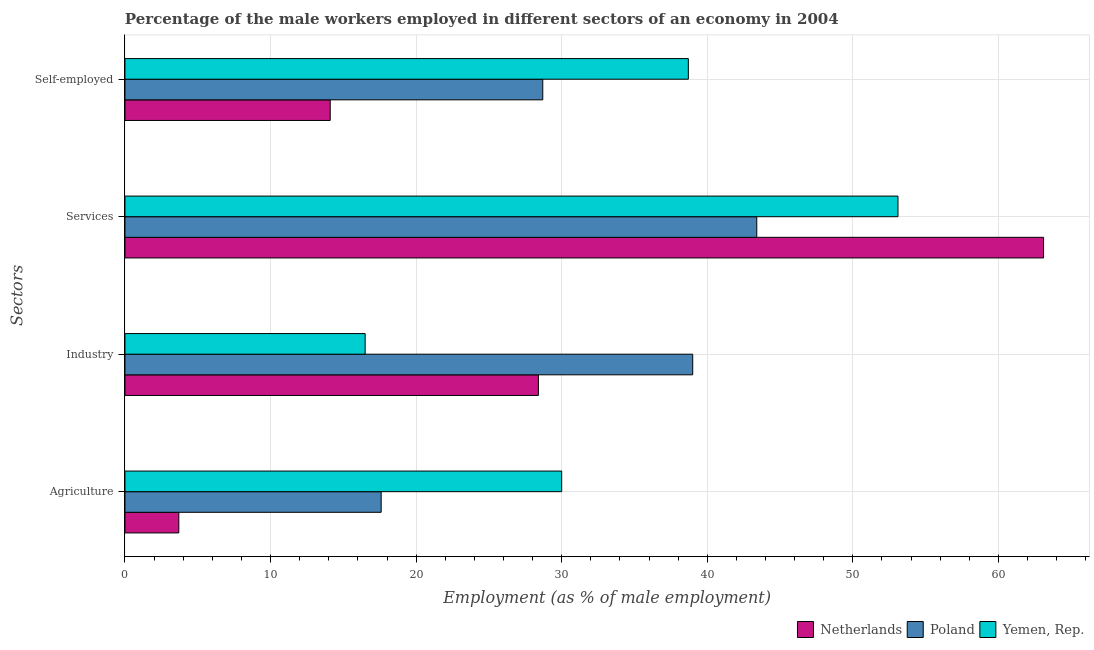Are the number of bars per tick equal to the number of legend labels?
Your answer should be compact. Yes. Are the number of bars on each tick of the Y-axis equal?
Offer a terse response. Yes. How many bars are there on the 4th tick from the bottom?
Offer a terse response. 3. What is the label of the 2nd group of bars from the top?
Provide a succinct answer. Services. What is the percentage of male workers in agriculture in Netherlands?
Your answer should be compact. 3.7. In which country was the percentage of male workers in agriculture maximum?
Your answer should be very brief. Yemen, Rep. What is the total percentage of self employed male workers in the graph?
Your answer should be compact. 81.5. What is the difference between the percentage of self employed male workers in Poland and that in Yemen, Rep.?
Provide a short and direct response. -10. What is the difference between the percentage of self employed male workers in Netherlands and the percentage of male workers in industry in Yemen, Rep.?
Ensure brevity in your answer.  -2.4. What is the average percentage of male workers in services per country?
Your answer should be compact. 53.2. What is the difference between the percentage of male workers in agriculture and percentage of male workers in industry in Yemen, Rep.?
Your answer should be very brief. 13.5. What is the ratio of the percentage of male workers in industry in Poland to that in Yemen, Rep.?
Your response must be concise. 2.36. Is the difference between the percentage of male workers in agriculture in Yemen, Rep. and Netherlands greater than the difference between the percentage of self employed male workers in Yemen, Rep. and Netherlands?
Keep it short and to the point. Yes. What is the difference between the highest and the second highest percentage of self employed male workers?
Provide a succinct answer. 10. What is the difference between the highest and the lowest percentage of male workers in services?
Your response must be concise. 19.7. Is the sum of the percentage of male workers in industry in Yemen, Rep. and Netherlands greater than the maximum percentage of male workers in services across all countries?
Provide a succinct answer. No. Is it the case that in every country, the sum of the percentage of self employed male workers and percentage of male workers in industry is greater than the sum of percentage of male workers in agriculture and percentage of male workers in services?
Provide a succinct answer. No. What does the 1st bar from the top in Services represents?
Provide a short and direct response. Yemen, Rep. What does the 3rd bar from the bottom in Industry represents?
Give a very brief answer. Yemen, Rep. Are the values on the major ticks of X-axis written in scientific E-notation?
Make the answer very short. No. Does the graph contain any zero values?
Give a very brief answer. No. Does the graph contain grids?
Ensure brevity in your answer.  Yes. How many legend labels are there?
Make the answer very short. 3. What is the title of the graph?
Your answer should be very brief. Percentage of the male workers employed in different sectors of an economy in 2004. What is the label or title of the X-axis?
Your response must be concise. Employment (as % of male employment). What is the label or title of the Y-axis?
Provide a succinct answer. Sectors. What is the Employment (as % of male employment) in Netherlands in Agriculture?
Offer a terse response. 3.7. What is the Employment (as % of male employment) in Poland in Agriculture?
Ensure brevity in your answer.  17.6. What is the Employment (as % of male employment) in Netherlands in Industry?
Your response must be concise. 28.4. What is the Employment (as % of male employment) in Yemen, Rep. in Industry?
Keep it short and to the point. 16.5. What is the Employment (as % of male employment) in Netherlands in Services?
Offer a terse response. 63.1. What is the Employment (as % of male employment) of Poland in Services?
Give a very brief answer. 43.4. What is the Employment (as % of male employment) of Yemen, Rep. in Services?
Provide a succinct answer. 53.1. What is the Employment (as % of male employment) of Netherlands in Self-employed?
Your response must be concise. 14.1. What is the Employment (as % of male employment) of Poland in Self-employed?
Give a very brief answer. 28.7. What is the Employment (as % of male employment) of Yemen, Rep. in Self-employed?
Ensure brevity in your answer.  38.7. Across all Sectors, what is the maximum Employment (as % of male employment) in Netherlands?
Provide a succinct answer. 63.1. Across all Sectors, what is the maximum Employment (as % of male employment) of Poland?
Make the answer very short. 43.4. Across all Sectors, what is the maximum Employment (as % of male employment) in Yemen, Rep.?
Provide a short and direct response. 53.1. Across all Sectors, what is the minimum Employment (as % of male employment) of Netherlands?
Keep it short and to the point. 3.7. Across all Sectors, what is the minimum Employment (as % of male employment) in Poland?
Offer a terse response. 17.6. Across all Sectors, what is the minimum Employment (as % of male employment) in Yemen, Rep.?
Your response must be concise. 16.5. What is the total Employment (as % of male employment) of Netherlands in the graph?
Give a very brief answer. 109.3. What is the total Employment (as % of male employment) of Poland in the graph?
Provide a short and direct response. 128.7. What is the total Employment (as % of male employment) of Yemen, Rep. in the graph?
Keep it short and to the point. 138.3. What is the difference between the Employment (as % of male employment) of Netherlands in Agriculture and that in Industry?
Your answer should be very brief. -24.7. What is the difference between the Employment (as % of male employment) in Poland in Agriculture and that in Industry?
Provide a short and direct response. -21.4. What is the difference between the Employment (as % of male employment) of Yemen, Rep. in Agriculture and that in Industry?
Offer a terse response. 13.5. What is the difference between the Employment (as % of male employment) in Netherlands in Agriculture and that in Services?
Offer a very short reply. -59.4. What is the difference between the Employment (as % of male employment) of Poland in Agriculture and that in Services?
Offer a terse response. -25.8. What is the difference between the Employment (as % of male employment) of Yemen, Rep. in Agriculture and that in Services?
Ensure brevity in your answer.  -23.1. What is the difference between the Employment (as % of male employment) of Netherlands in Agriculture and that in Self-employed?
Give a very brief answer. -10.4. What is the difference between the Employment (as % of male employment) of Yemen, Rep. in Agriculture and that in Self-employed?
Provide a succinct answer. -8.7. What is the difference between the Employment (as % of male employment) in Netherlands in Industry and that in Services?
Make the answer very short. -34.7. What is the difference between the Employment (as % of male employment) in Yemen, Rep. in Industry and that in Services?
Make the answer very short. -36.6. What is the difference between the Employment (as % of male employment) in Poland in Industry and that in Self-employed?
Provide a short and direct response. 10.3. What is the difference between the Employment (as % of male employment) in Yemen, Rep. in Industry and that in Self-employed?
Keep it short and to the point. -22.2. What is the difference between the Employment (as % of male employment) in Netherlands in Services and that in Self-employed?
Keep it short and to the point. 49. What is the difference between the Employment (as % of male employment) of Netherlands in Agriculture and the Employment (as % of male employment) of Poland in Industry?
Ensure brevity in your answer.  -35.3. What is the difference between the Employment (as % of male employment) in Poland in Agriculture and the Employment (as % of male employment) in Yemen, Rep. in Industry?
Your response must be concise. 1.1. What is the difference between the Employment (as % of male employment) of Netherlands in Agriculture and the Employment (as % of male employment) of Poland in Services?
Ensure brevity in your answer.  -39.7. What is the difference between the Employment (as % of male employment) of Netherlands in Agriculture and the Employment (as % of male employment) of Yemen, Rep. in Services?
Your response must be concise. -49.4. What is the difference between the Employment (as % of male employment) of Poland in Agriculture and the Employment (as % of male employment) of Yemen, Rep. in Services?
Your answer should be very brief. -35.5. What is the difference between the Employment (as % of male employment) in Netherlands in Agriculture and the Employment (as % of male employment) in Poland in Self-employed?
Provide a short and direct response. -25. What is the difference between the Employment (as % of male employment) in Netherlands in Agriculture and the Employment (as % of male employment) in Yemen, Rep. in Self-employed?
Provide a short and direct response. -35. What is the difference between the Employment (as % of male employment) of Poland in Agriculture and the Employment (as % of male employment) of Yemen, Rep. in Self-employed?
Provide a succinct answer. -21.1. What is the difference between the Employment (as % of male employment) of Netherlands in Industry and the Employment (as % of male employment) of Yemen, Rep. in Services?
Your answer should be very brief. -24.7. What is the difference between the Employment (as % of male employment) in Poland in Industry and the Employment (as % of male employment) in Yemen, Rep. in Services?
Offer a very short reply. -14.1. What is the difference between the Employment (as % of male employment) in Netherlands in Industry and the Employment (as % of male employment) in Poland in Self-employed?
Make the answer very short. -0.3. What is the difference between the Employment (as % of male employment) of Poland in Industry and the Employment (as % of male employment) of Yemen, Rep. in Self-employed?
Offer a terse response. 0.3. What is the difference between the Employment (as % of male employment) of Netherlands in Services and the Employment (as % of male employment) of Poland in Self-employed?
Your answer should be compact. 34.4. What is the difference between the Employment (as % of male employment) of Netherlands in Services and the Employment (as % of male employment) of Yemen, Rep. in Self-employed?
Provide a short and direct response. 24.4. What is the average Employment (as % of male employment) in Netherlands per Sectors?
Make the answer very short. 27.32. What is the average Employment (as % of male employment) in Poland per Sectors?
Make the answer very short. 32.17. What is the average Employment (as % of male employment) in Yemen, Rep. per Sectors?
Give a very brief answer. 34.58. What is the difference between the Employment (as % of male employment) of Netherlands and Employment (as % of male employment) of Poland in Agriculture?
Your response must be concise. -13.9. What is the difference between the Employment (as % of male employment) in Netherlands and Employment (as % of male employment) in Yemen, Rep. in Agriculture?
Offer a terse response. -26.3. What is the difference between the Employment (as % of male employment) of Poland and Employment (as % of male employment) of Yemen, Rep. in Agriculture?
Offer a terse response. -12.4. What is the difference between the Employment (as % of male employment) of Netherlands and Employment (as % of male employment) of Poland in Industry?
Your answer should be very brief. -10.6. What is the difference between the Employment (as % of male employment) in Poland and Employment (as % of male employment) in Yemen, Rep. in Industry?
Give a very brief answer. 22.5. What is the difference between the Employment (as % of male employment) of Poland and Employment (as % of male employment) of Yemen, Rep. in Services?
Provide a short and direct response. -9.7. What is the difference between the Employment (as % of male employment) in Netherlands and Employment (as % of male employment) in Poland in Self-employed?
Provide a short and direct response. -14.6. What is the difference between the Employment (as % of male employment) of Netherlands and Employment (as % of male employment) of Yemen, Rep. in Self-employed?
Your answer should be compact. -24.6. What is the difference between the Employment (as % of male employment) of Poland and Employment (as % of male employment) of Yemen, Rep. in Self-employed?
Make the answer very short. -10. What is the ratio of the Employment (as % of male employment) in Netherlands in Agriculture to that in Industry?
Your response must be concise. 0.13. What is the ratio of the Employment (as % of male employment) of Poland in Agriculture to that in Industry?
Your answer should be very brief. 0.45. What is the ratio of the Employment (as % of male employment) in Yemen, Rep. in Agriculture to that in Industry?
Ensure brevity in your answer.  1.82. What is the ratio of the Employment (as % of male employment) of Netherlands in Agriculture to that in Services?
Offer a very short reply. 0.06. What is the ratio of the Employment (as % of male employment) in Poland in Agriculture to that in Services?
Your response must be concise. 0.41. What is the ratio of the Employment (as % of male employment) in Yemen, Rep. in Agriculture to that in Services?
Keep it short and to the point. 0.56. What is the ratio of the Employment (as % of male employment) of Netherlands in Agriculture to that in Self-employed?
Your response must be concise. 0.26. What is the ratio of the Employment (as % of male employment) of Poland in Agriculture to that in Self-employed?
Your response must be concise. 0.61. What is the ratio of the Employment (as % of male employment) in Yemen, Rep. in Agriculture to that in Self-employed?
Provide a short and direct response. 0.78. What is the ratio of the Employment (as % of male employment) in Netherlands in Industry to that in Services?
Keep it short and to the point. 0.45. What is the ratio of the Employment (as % of male employment) of Poland in Industry to that in Services?
Make the answer very short. 0.9. What is the ratio of the Employment (as % of male employment) of Yemen, Rep. in Industry to that in Services?
Provide a short and direct response. 0.31. What is the ratio of the Employment (as % of male employment) in Netherlands in Industry to that in Self-employed?
Give a very brief answer. 2.01. What is the ratio of the Employment (as % of male employment) in Poland in Industry to that in Self-employed?
Your answer should be compact. 1.36. What is the ratio of the Employment (as % of male employment) in Yemen, Rep. in Industry to that in Self-employed?
Provide a succinct answer. 0.43. What is the ratio of the Employment (as % of male employment) of Netherlands in Services to that in Self-employed?
Keep it short and to the point. 4.48. What is the ratio of the Employment (as % of male employment) in Poland in Services to that in Self-employed?
Offer a terse response. 1.51. What is the ratio of the Employment (as % of male employment) in Yemen, Rep. in Services to that in Self-employed?
Provide a succinct answer. 1.37. What is the difference between the highest and the second highest Employment (as % of male employment) in Netherlands?
Ensure brevity in your answer.  34.7. What is the difference between the highest and the second highest Employment (as % of male employment) of Poland?
Provide a short and direct response. 4.4. What is the difference between the highest and the second highest Employment (as % of male employment) of Yemen, Rep.?
Your response must be concise. 14.4. What is the difference between the highest and the lowest Employment (as % of male employment) of Netherlands?
Your response must be concise. 59.4. What is the difference between the highest and the lowest Employment (as % of male employment) of Poland?
Provide a short and direct response. 25.8. What is the difference between the highest and the lowest Employment (as % of male employment) in Yemen, Rep.?
Keep it short and to the point. 36.6. 